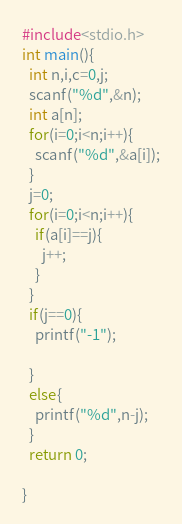<code> <loc_0><loc_0><loc_500><loc_500><_C_>#include<stdio.h>
int main(){
  int n,i,c=0,j;
  scanf("%d",&n);
  int a[n];
  for(i=0;i<n;i++){
    scanf("%d",&a[i]);
  }
  j=0;
  for(i=0;i<n;i++){
    if(a[i]==j){
      j++;
    }
  }
  if(j==0){
    printf("-1");
    
  }
  else{
    printf("%d",n-j);
  }
  return 0;
  
}</code> 